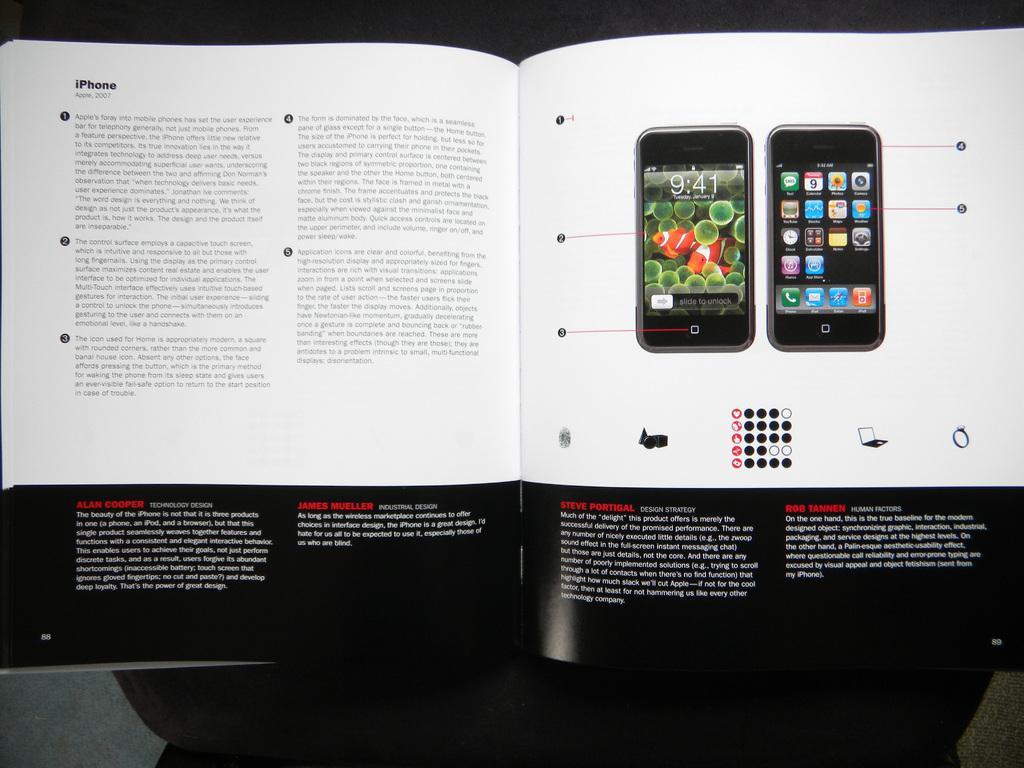How would you summarize this image in a sentence or two? In the image we can see a book, in the book we can see a picture of mobile phones. This is a printed text. 